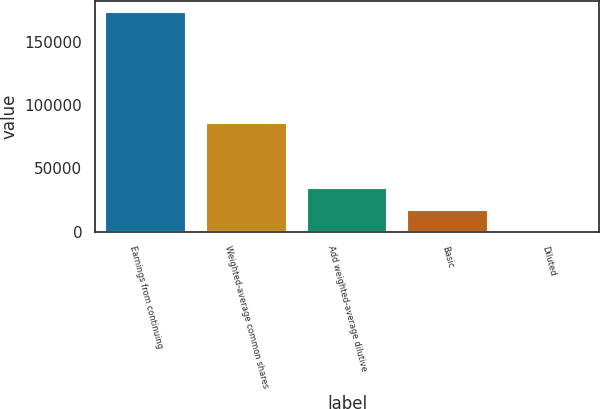Convert chart. <chart><loc_0><loc_0><loc_500><loc_500><bar_chart><fcel>Earnings from continuing<fcel>Weighted-average common shares<fcel>Add weighted-average dilutive<fcel>Basic<fcel>Diluted<nl><fcel>173922<fcel>86127.9<fcel>34786.4<fcel>17394.5<fcel>2.52<nl></chart> 